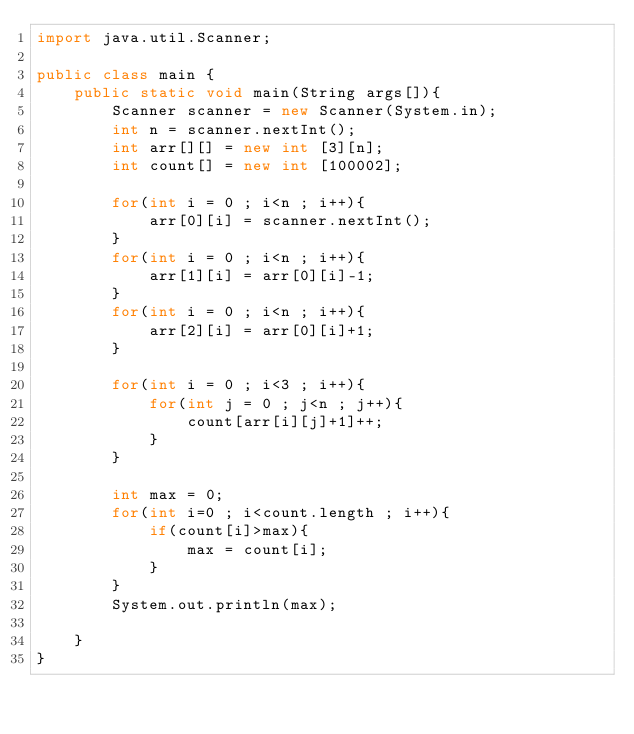<code> <loc_0><loc_0><loc_500><loc_500><_Java_>import java.util.Scanner;

public class main {
	public static void main(String args[]){
		Scanner scanner = new Scanner(System.in);
		int n = scanner.nextInt();
		int arr[][] = new int [3][n];
		int count[] = new int [100002]; 
		
		for(int i = 0 ; i<n ; i++){
			arr[0][i] = scanner.nextInt();
		}
		for(int i = 0 ; i<n ; i++){
			arr[1][i] = arr[0][i]-1;
		}
		for(int i = 0 ; i<n ; i++){
			arr[2][i] = arr[0][i]+1;
		}
		
		for(int i = 0 ; i<3 ; i++){
			for(int j = 0 ; j<n ; j++){
				count[arr[i][j]+1]++;
			}
		}
		
		int max = 0;
		for(int i=0 ; i<count.length ; i++){
			if(count[i]>max){
				max = count[i];
			}
		}
		System.out.println(max);
		
	}
}
</code> 